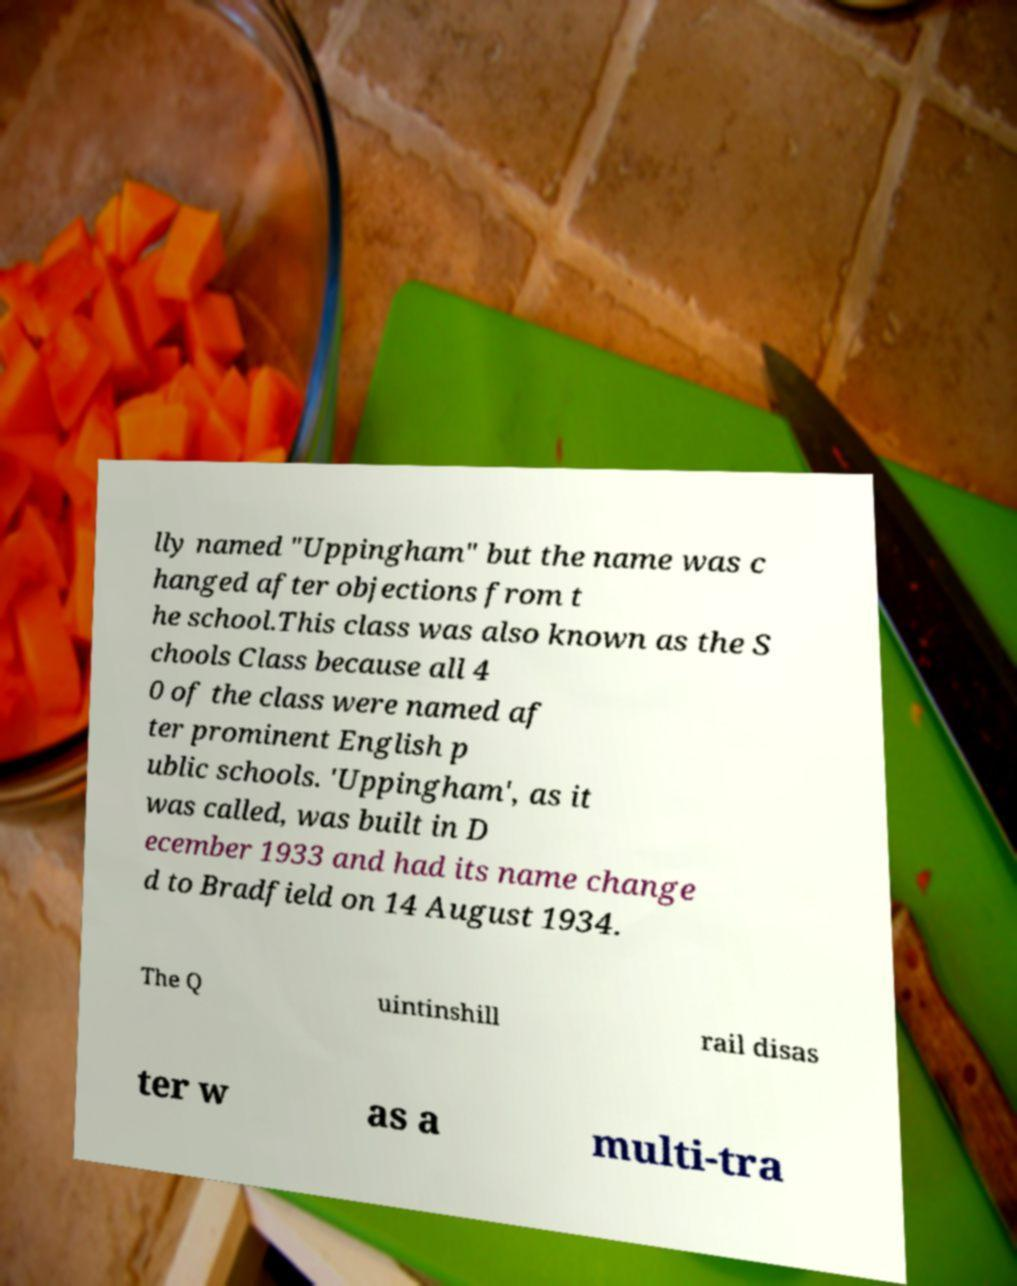Could you assist in decoding the text presented in this image and type it out clearly? lly named "Uppingham" but the name was c hanged after objections from t he school.This class was also known as the S chools Class because all 4 0 of the class were named af ter prominent English p ublic schools. 'Uppingham', as it was called, was built in D ecember 1933 and had its name change d to Bradfield on 14 August 1934. The Q uintinshill rail disas ter w as a multi-tra 